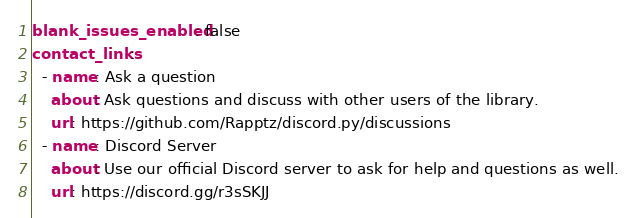Convert code to text. <code><loc_0><loc_0><loc_500><loc_500><_YAML_>blank_issues_enabled: false
contact_links:
  - name: Ask a question
    about: Ask questions and discuss with other users of the library.
    url: https://github.com/Rapptz/discord.py/discussions
  - name: Discord Server
    about: Use our official Discord server to ask for help and questions as well.
    url: https://discord.gg/r3sSKJJ
</code> 